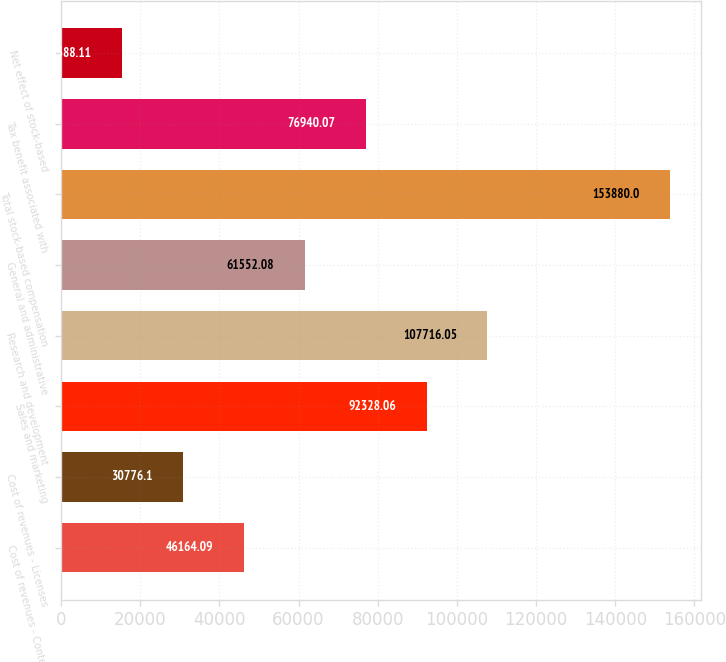Convert chart to OTSL. <chart><loc_0><loc_0><loc_500><loc_500><bar_chart><fcel>Cost of revenues - Content<fcel>Cost of revenues - Licenses<fcel>Sales and marketing<fcel>Research and development<fcel>General and administrative<fcel>Total stock-based compensation<fcel>Tax benefit associated with<fcel>Net effect of stock-based<nl><fcel>46164.1<fcel>30776.1<fcel>92328.1<fcel>107716<fcel>61552.1<fcel>153880<fcel>76940.1<fcel>15388.1<nl></chart> 